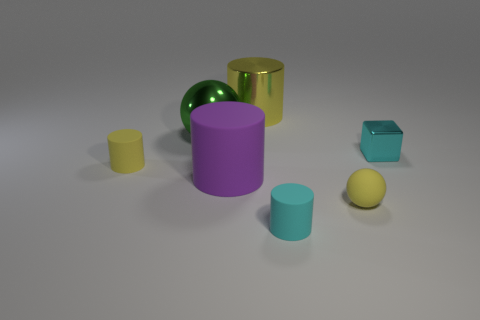Is there any other thing that is the same shape as the tiny metallic thing?
Provide a succinct answer. No. What is the thing that is both on the right side of the tiny cyan matte cylinder and on the left side of the cyan cube made of?
Your answer should be compact. Rubber. Do the cyan thing in front of the block and the big object that is in front of the cyan metallic thing have the same shape?
Give a very brief answer. Yes. There is a tiny object that is the same color as the block; what shape is it?
Your response must be concise. Cylinder. What number of objects are large things that are right of the big ball or tiny cyan shiny things?
Keep it short and to the point. 3. Do the purple cylinder and the green ball have the same size?
Provide a short and direct response. Yes. The small matte cylinder to the right of the large green ball is what color?
Keep it short and to the point. Cyan. What is the size of the purple thing that is the same material as the tiny cyan cylinder?
Provide a succinct answer. Large. Do the cyan cylinder and the green thing that is left of the yellow metallic object have the same size?
Provide a succinct answer. No. There is a tiny yellow object that is to the left of the big green ball; what is its material?
Your answer should be very brief. Rubber. 